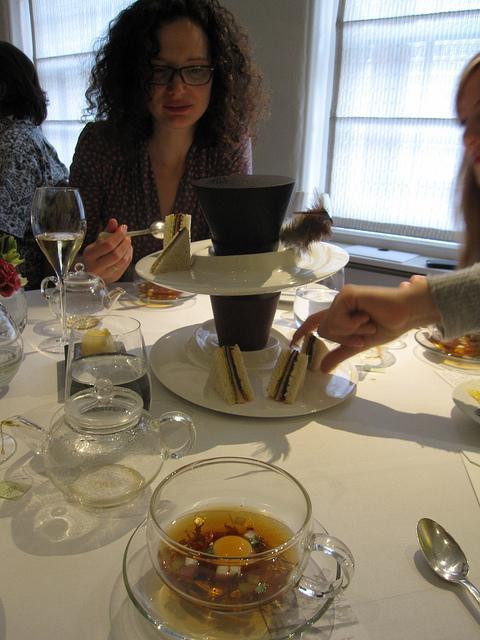How many cups are there?
Give a very brief answer. 2. How many people are visible?
Give a very brief answer. 3. How many wine glasses are there?
Give a very brief answer. 3. How many cars are there?
Give a very brief answer. 0. 